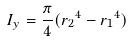Convert formula to latex. <formula><loc_0><loc_0><loc_500><loc_500>I _ { y } = \frac { \pi } { 4 } ( { r _ { 2 } } ^ { 4 } - { r _ { 1 } } ^ { 4 } )</formula> 